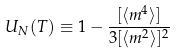Convert formula to latex. <formula><loc_0><loc_0><loc_500><loc_500>U _ { N } ( T ) \equiv 1 - \frac { [ \langle m ^ { 4 } \rangle ] } { 3 [ \langle m ^ { 2 } \rangle ] ^ { 2 } }</formula> 